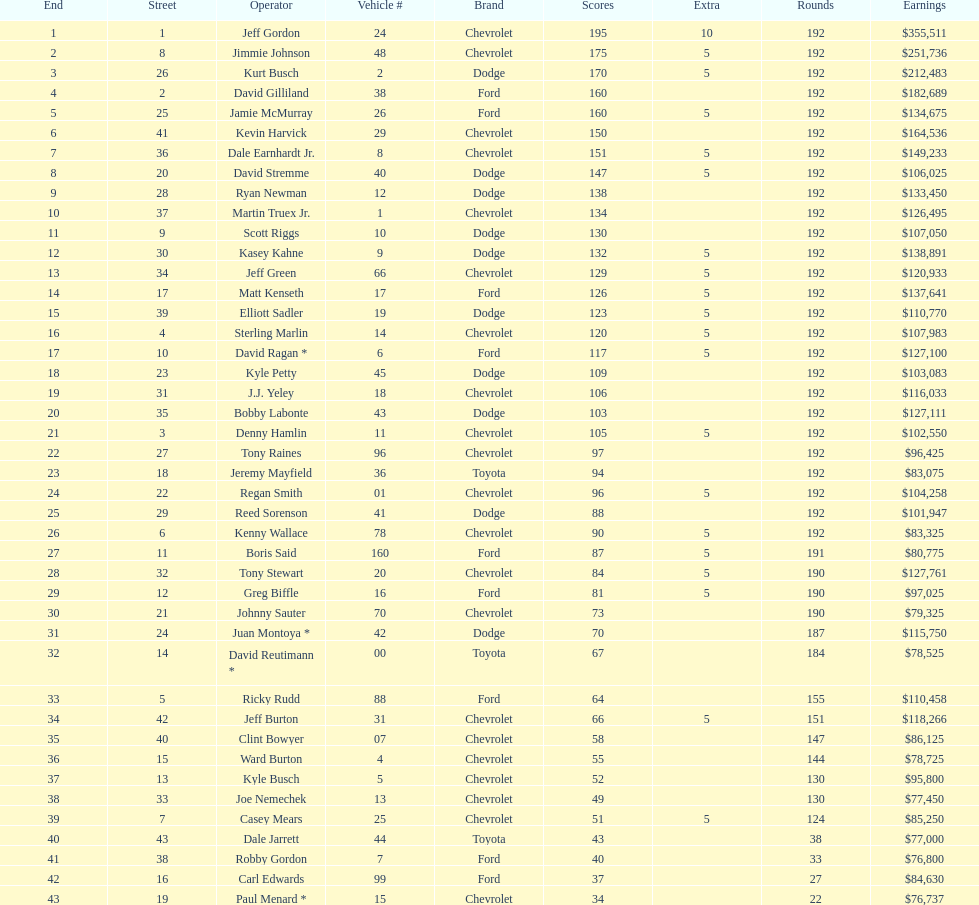Who got the most bonus points? Jeff Gordon. 